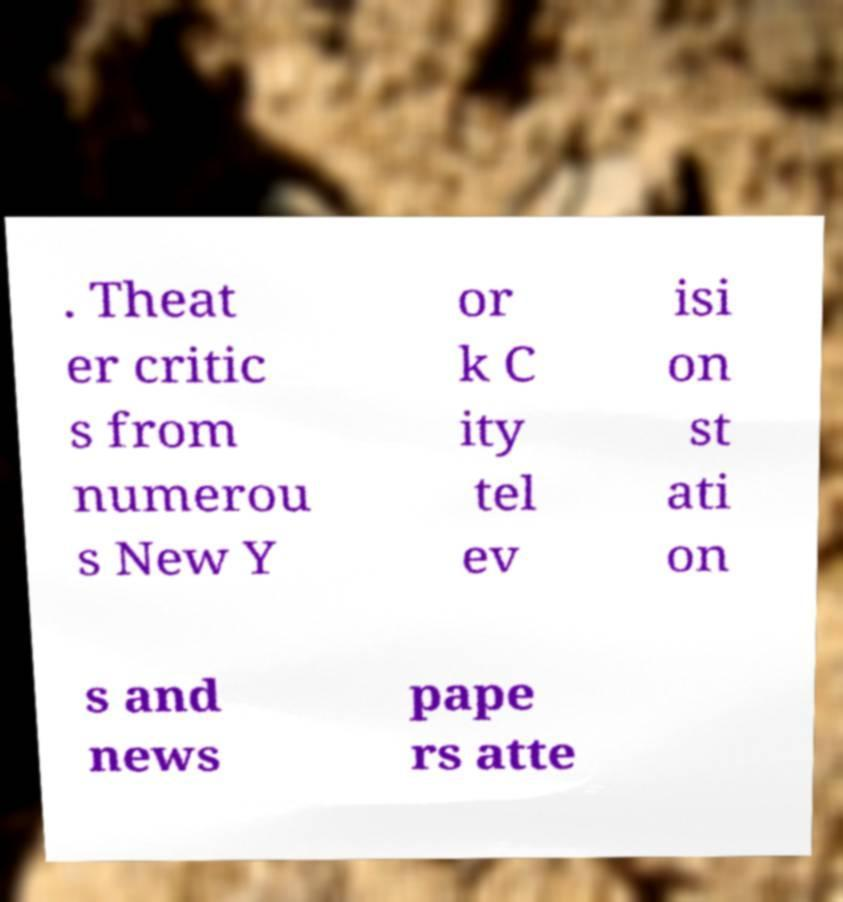Can you read and provide the text displayed in the image?This photo seems to have some interesting text. Can you extract and type it out for me? . Theat er critic s from numerou s New Y or k C ity tel ev isi on st ati on s and news pape rs atte 